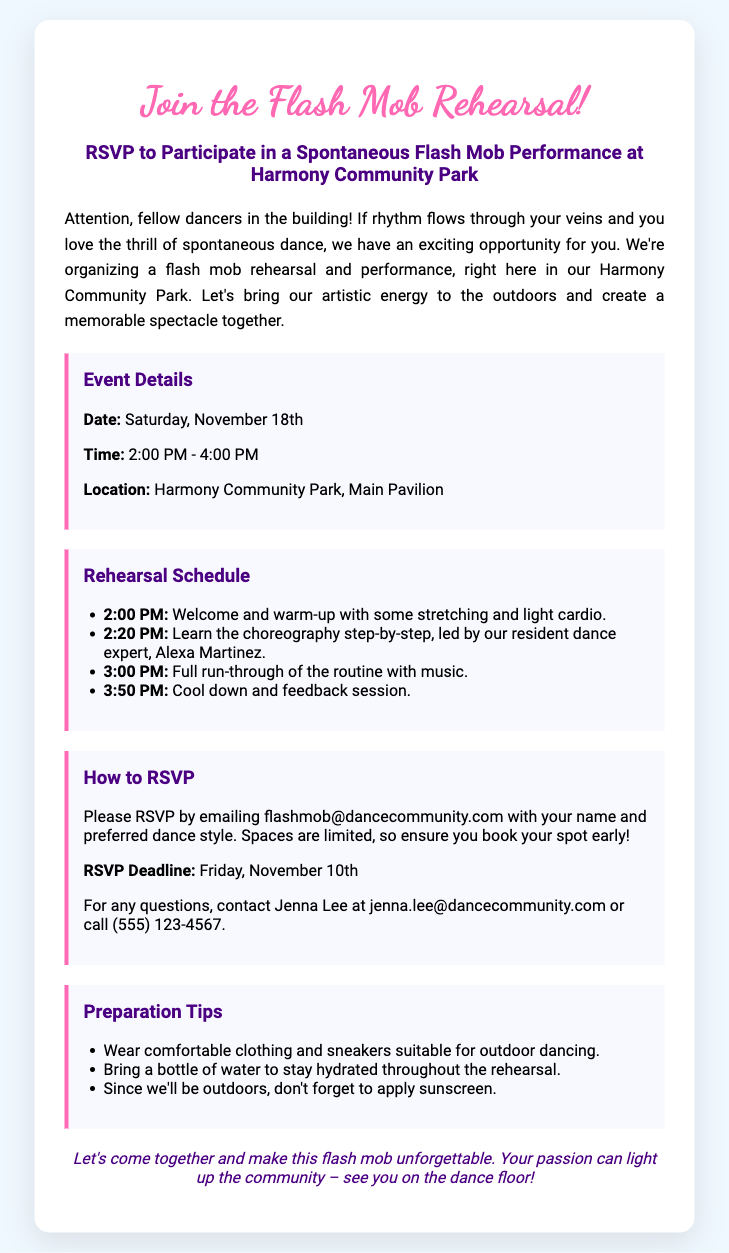what is the date of the flash mob rehearsal? The date of the flash mob rehearsal is explicitly stated in the document.
Answer: Saturday, November 18th what time does the rehearsal start? The document mentions the start time of the rehearsal clearly.
Answer: 2:00 PM who is leading the choreography session? The document specifies the name of the person leading the choreography.
Answer: Alexa Martinez what is the RSVP deadline? The document includes the deadline for RSVPs.
Answer: Friday, November 10th how can participants RSVP? The document describes the method of RSVP.
Answer: Emailing flashmob@dancecommunity.com what is the maximum duration of the event? To find the duration, subtract the start time from the end time detailed in the document.
Answer: 2 hours what should participants bring for hydration? The document includes suggestions for what to bring.
Answer: A bottle of water what color is the event headline text? The document specifies the color of the event title, which is mentioned clearly.
Answer: #ff69b4 what is the location of the event? The document states where the flash mob rehearsal will take place.
Answer: Harmony Community Park, Main Pavilion 